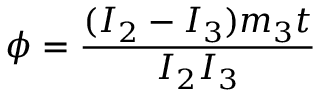<formula> <loc_0><loc_0><loc_500><loc_500>\phi = \frac { ( I _ { 2 } - I _ { 3 } ) m _ { 3 } t } { I _ { 2 } I _ { 3 } }</formula> 